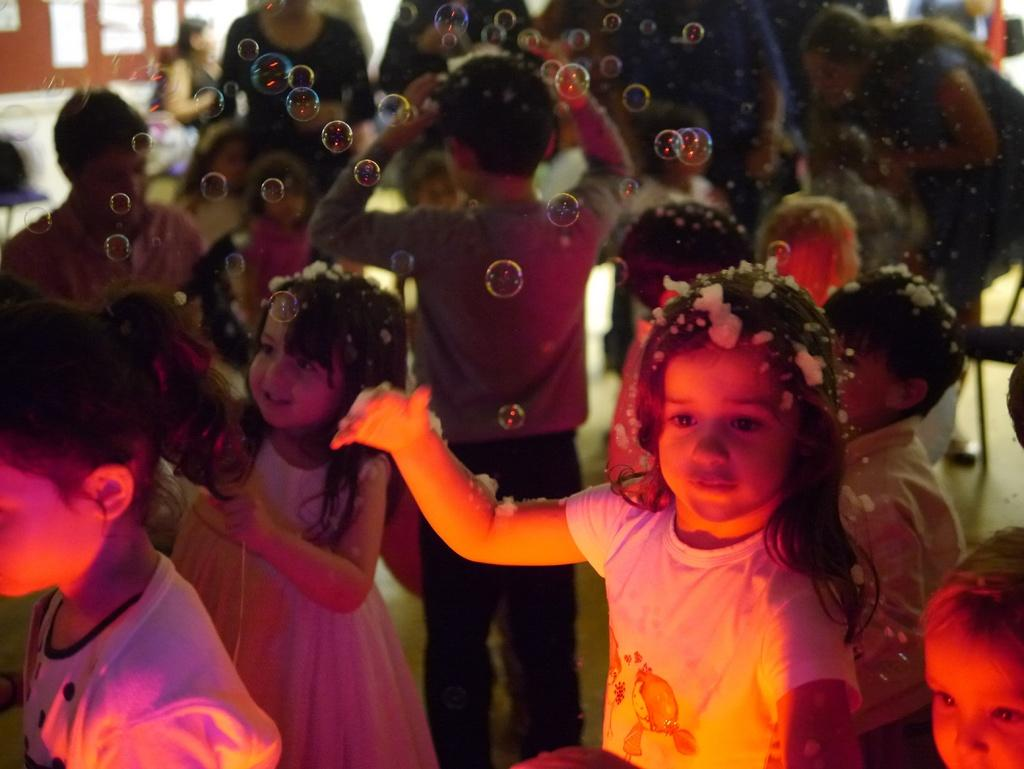How many children are present in the image? There are many children in the image. What are the children doing in the image? The children are standing in the image. What are the children wearing in the image? The children are wearing clothes in the image. What else can be seen in the image besides the children? There are foam bubbles and the floor visible in the image. How is the background of the image depicted? The background of the image is blurred. What type of vest can be seen on the children in the image? There is no vest visible on the children in the image. How many eggs are being held by the children in the image? There are no eggs present in the image. 